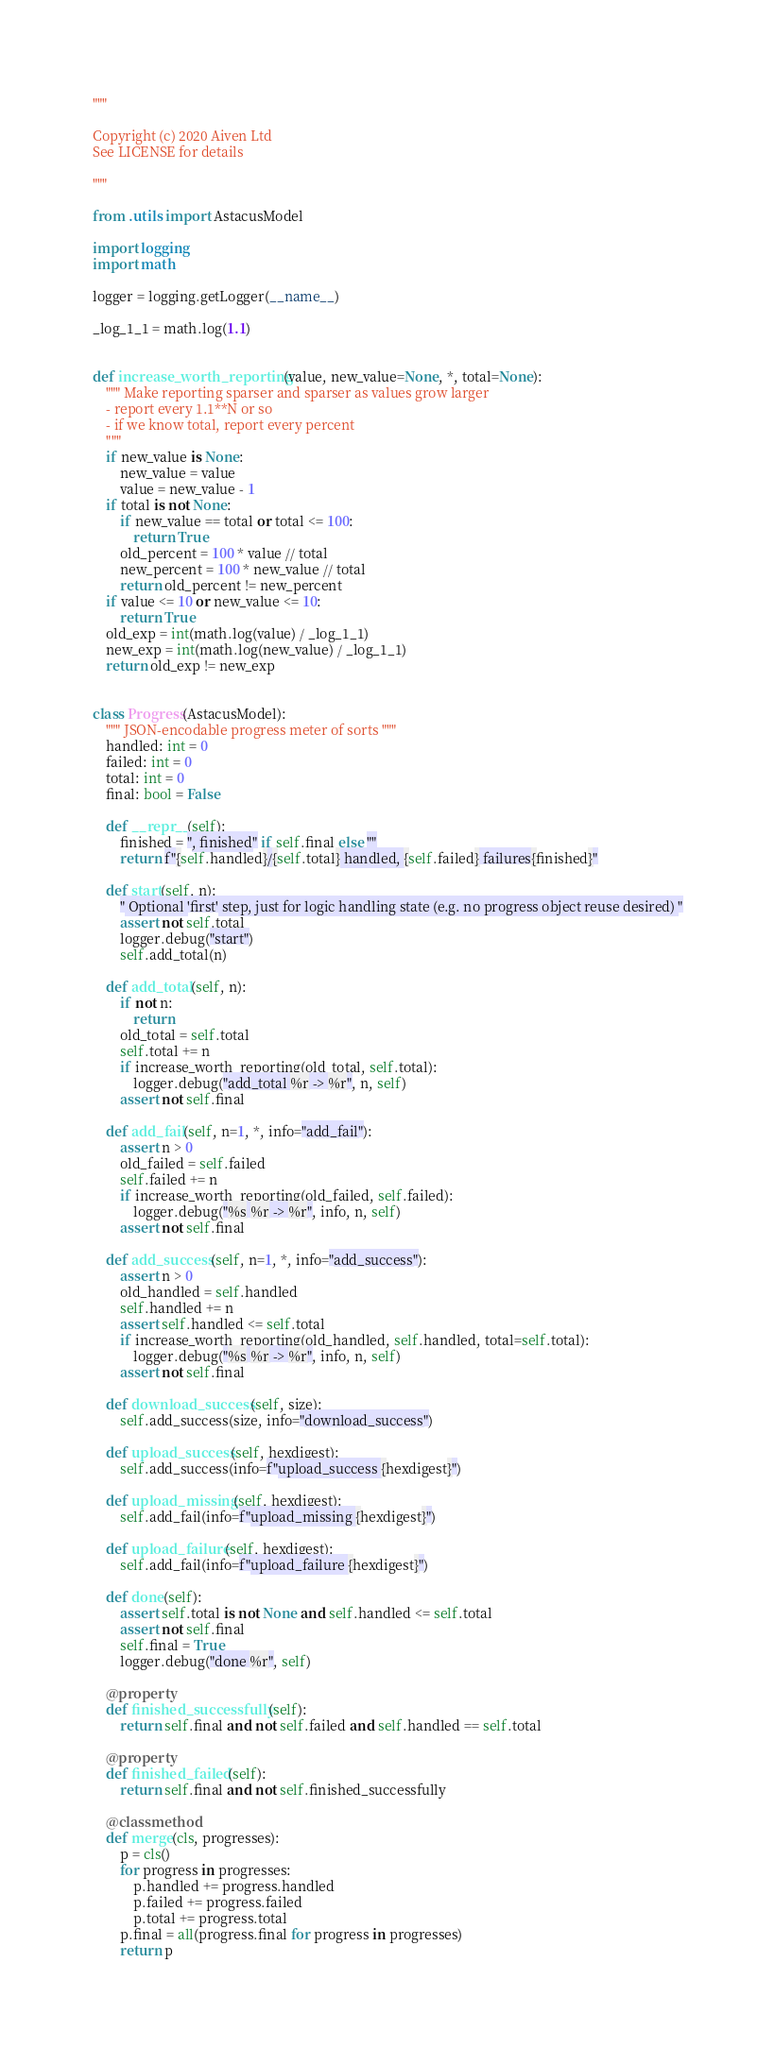<code> <loc_0><loc_0><loc_500><loc_500><_Python_>"""

Copyright (c) 2020 Aiven Ltd
See LICENSE for details

"""

from .utils import AstacusModel

import logging
import math

logger = logging.getLogger(__name__)

_log_1_1 = math.log(1.1)


def increase_worth_reporting(value, new_value=None, *, total=None):
    """ Make reporting sparser and sparser as values grow larger
    - report every 1.1**N or so
    - if we know total, report every percent
    """
    if new_value is None:
        new_value = value
        value = new_value - 1
    if total is not None:
        if new_value == total or total <= 100:
            return True
        old_percent = 100 * value // total
        new_percent = 100 * new_value // total
        return old_percent != new_percent
    if value <= 10 or new_value <= 10:
        return True
    old_exp = int(math.log(value) / _log_1_1)
    new_exp = int(math.log(new_value) / _log_1_1)
    return old_exp != new_exp


class Progress(AstacusModel):
    """ JSON-encodable progress meter of sorts """
    handled: int = 0
    failed: int = 0
    total: int = 0
    final: bool = False

    def __repr__(self):
        finished = ", finished" if self.final else ""
        return f"{self.handled}/{self.total} handled, {self.failed} failures{finished}"

    def start(self, n):
        " Optional 'first' step, just for logic handling state (e.g. no progress object reuse desired) "
        assert not self.total
        logger.debug("start")
        self.add_total(n)

    def add_total(self, n):
        if not n:
            return
        old_total = self.total
        self.total += n
        if increase_worth_reporting(old_total, self.total):
            logger.debug("add_total %r -> %r", n, self)
        assert not self.final

    def add_fail(self, n=1, *, info="add_fail"):
        assert n > 0
        old_failed = self.failed
        self.failed += n
        if increase_worth_reporting(old_failed, self.failed):
            logger.debug("%s %r -> %r", info, n, self)
        assert not self.final

    def add_success(self, n=1, *, info="add_success"):
        assert n > 0
        old_handled = self.handled
        self.handled += n
        assert self.handled <= self.total
        if increase_worth_reporting(old_handled, self.handled, total=self.total):
            logger.debug("%s %r -> %r", info, n, self)
        assert not self.final

    def download_success(self, size):
        self.add_success(size, info="download_success")

    def upload_success(self, hexdigest):
        self.add_success(info=f"upload_success {hexdigest}")

    def upload_missing(self, hexdigest):
        self.add_fail(info=f"upload_missing {hexdigest}")

    def upload_failure(self, hexdigest):
        self.add_fail(info=f"upload_failure {hexdigest}")

    def done(self):
        assert self.total is not None and self.handled <= self.total
        assert not self.final
        self.final = True
        logger.debug("done %r", self)

    @property
    def finished_successfully(self):
        return self.final and not self.failed and self.handled == self.total

    @property
    def finished_failed(self):
        return self.final and not self.finished_successfully

    @classmethod
    def merge(cls, progresses):
        p = cls()
        for progress in progresses:
            p.handled += progress.handled
            p.failed += progress.failed
            p.total += progress.total
        p.final = all(progress.final for progress in progresses)
        return p
</code> 